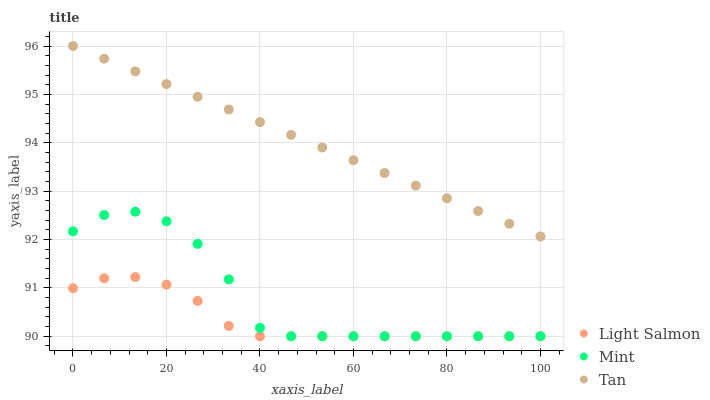Does Light Salmon have the minimum area under the curve?
Answer yes or no. Yes. Does Tan have the maximum area under the curve?
Answer yes or no. Yes. Does Mint have the minimum area under the curve?
Answer yes or no. No. Does Mint have the maximum area under the curve?
Answer yes or no. No. Is Tan the smoothest?
Answer yes or no. Yes. Is Mint the roughest?
Answer yes or no. Yes. Is Mint the smoothest?
Answer yes or no. No. Is Tan the roughest?
Answer yes or no. No. Does Light Salmon have the lowest value?
Answer yes or no. Yes. Does Tan have the lowest value?
Answer yes or no. No. Does Tan have the highest value?
Answer yes or no. Yes. Does Mint have the highest value?
Answer yes or no. No. Is Mint less than Tan?
Answer yes or no. Yes. Is Tan greater than Light Salmon?
Answer yes or no. Yes. Does Mint intersect Light Salmon?
Answer yes or no. Yes. Is Mint less than Light Salmon?
Answer yes or no. No. Is Mint greater than Light Salmon?
Answer yes or no. No. Does Mint intersect Tan?
Answer yes or no. No. 